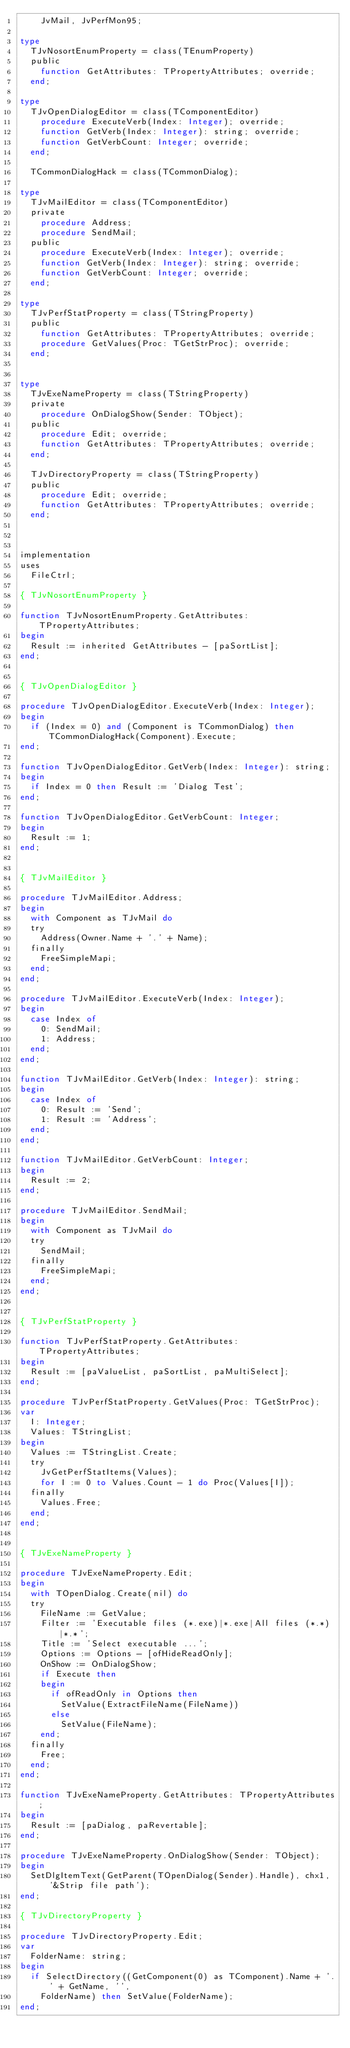Convert code to text. <code><loc_0><loc_0><loc_500><loc_500><_Pascal_>    JvMail, JvPerfMon95;

type
  TJvNosortEnumProperty = class(TEnumProperty)
  public
    function GetAttributes: TPropertyAttributes; override;
  end;

type
  TJvOpenDialogEditor = class(TComponentEditor)
    procedure ExecuteVerb(Index: Integer); override;
    function GetVerb(Index: Integer): string; override;
    function GetVerbCount: Integer; override;
  end;

  TCommonDialogHack = class(TCommonDialog);

type
  TJvMailEditor = class(TComponentEditor)
  private
    procedure Address;
    procedure SendMail;
  public
    procedure ExecuteVerb(Index: Integer); override;
    function GetVerb(Index: Integer): string; override;
    function GetVerbCount: Integer; override;
  end;

type
  TJvPerfStatProperty = class(TStringProperty)
  public
    function GetAttributes: TPropertyAttributes; override;
    procedure GetValues(Proc: TGetStrProc); override;
  end;


type
  TJvExeNameProperty = class(TStringProperty)
  private
    procedure OnDialogShow(Sender: TObject);
  public
    procedure Edit; override;
    function GetAttributes: TPropertyAttributes; override;
  end;

  TJvDirectoryProperty = class(TStringProperty)
  public
    procedure Edit; override;
    function GetAttributes: TPropertyAttributes; override;
  end;



implementation
uses
  FileCtrl;
  
{ TJvNosortEnumProperty }

function TJvNosortEnumProperty.GetAttributes: TPropertyAttributes;
begin
  Result := inherited GetAttributes - [paSortList];
end;


{ TJvOpenDialogEditor }

procedure TJvOpenDialogEditor.ExecuteVerb(Index: Integer);
begin
  if (Index = 0) and (Component is TCommonDialog) then TCommonDialogHack(Component).Execute;
end;

function TJvOpenDialogEditor.GetVerb(Index: Integer): string;
begin
  if Index = 0 then Result := 'Dialog Test';
end;

function TJvOpenDialogEditor.GetVerbCount: Integer;
begin
  Result := 1;
end;


{ TJvMailEditor }

procedure TJvMailEditor.Address;
begin
  with Component as TJvMail do
  try
    Address(Owner.Name + '.' + Name);
  finally
    FreeSimpleMapi;
  end;
end;

procedure TJvMailEditor.ExecuteVerb(Index: Integer);
begin
  case Index of
    0: SendMail;
    1: Address;
  end;
end;

function TJvMailEditor.GetVerb(Index: Integer): string;
begin
  case Index of
    0: Result := 'Send';
    1: Result := 'Address';
  end;
end;

function TJvMailEditor.GetVerbCount: Integer;
begin
  Result := 2;
end;

procedure TJvMailEditor.SendMail;
begin
  with Component as TJvMail do
  try
    SendMail;
  finally
    FreeSimpleMapi;
  end;
end;


{ TJvPerfStatProperty }

function TJvPerfStatProperty.GetAttributes: TPropertyAttributes;
begin
  Result := [paValueList, paSortList, paMultiSelect];
end;

procedure TJvPerfStatProperty.GetValues(Proc: TGetStrProc);
var
  I: Integer;
  Values: TStringList;
begin
  Values := TStringList.Create;
  try
    JvGetPerfStatItems(Values);
    for I := 0 to Values.Count - 1 do Proc(Values[I]);
  finally
    Values.Free;
  end;
end;


{ TJvExeNameProperty }

procedure TJvExeNameProperty.Edit;
begin
  with TOpenDialog.Create(nil) do
  try
    FileName := GetValue;
    Filter := 'Executable files (*.exe)|*.exe|All files (*.*)|*.*';
    Title := 'Select executable ...';
    Options := Options - [ofHideReadOnly];
    OnShow := OnDialogShow;
    if Execute then
    begin
      if ofReadOnly in Options then
        SetValue(ExtractFileName(FileName))
      else
        SetValue(FileName);
    end;
  finally
    Free;
  end;
end;

function TJvExeNameProperty.GetAttributes: TPropertyAttributes;
begin
  Result := [paDialog, paRevertable];
end;

procedure TJvExeNameProperty.OnDialogShow(Sender: TObject);
begin
  SetDlgItemText(GetParent(TOpenDialog(Sender).Handle), chx1, '&Strip file path');
end;

{ TJvDirectoryProperty }

procedure TJvDirectoryProperty.Edit;
var
  FolderName: string;
begin
  if SelectDirectory((GetComponent(0) as TComponent).Name + '.' + GetName, '',
    FolderName) then SetValue(FolderName);
end;
</code> 